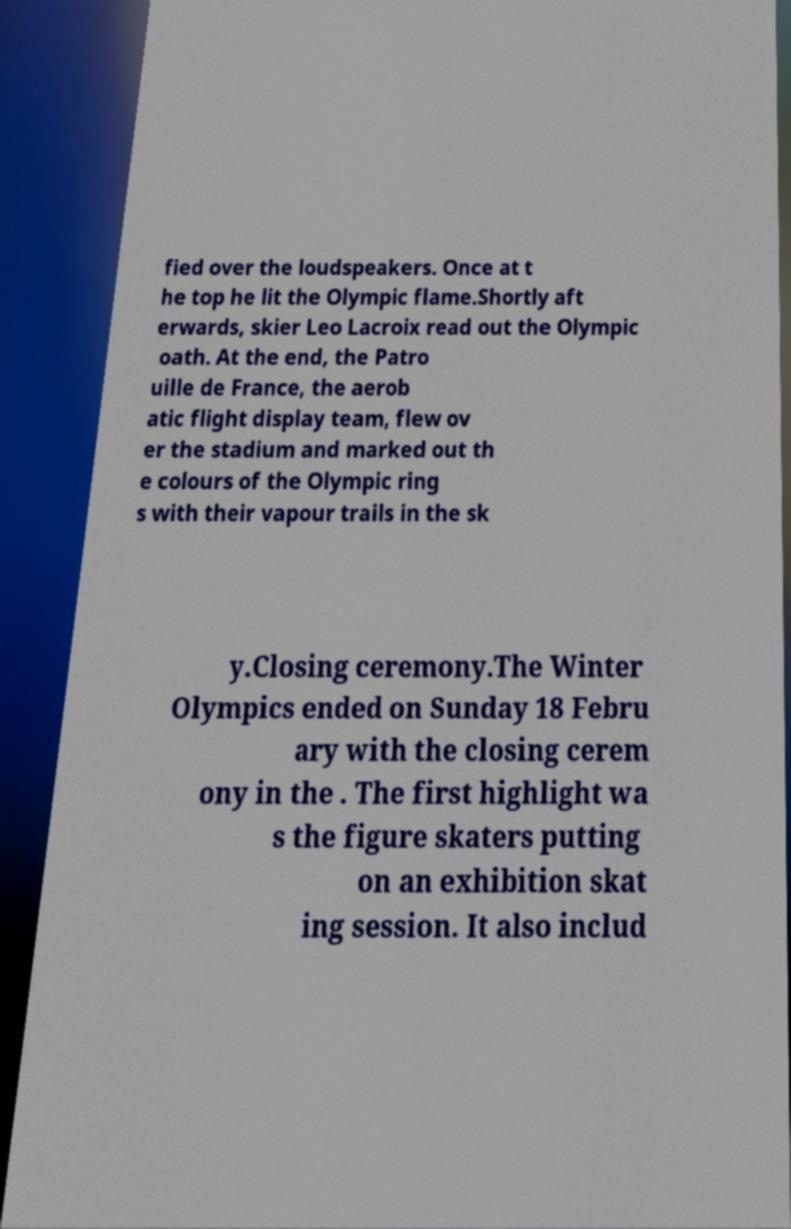Could you assist in decoding the text presented in this image and type it out clearly? fied over the loudspeakers. Once at t he top he lit the Olympic flame.Shortly aft erwards, skier Leo Lacroix read out the Olympic oath. At the end, the Patro uille de France, the aerob atic flight display team, flew ov er the stadium and marked out th e colours of the Olympic ring s with their vapour trails in the sk y.Closing ceremony.The Winter Olympics ended on Sunday 18 Febru ary with the closing cerem ony in the . The first highlight wa s the figure skaters putting on an exhibition skat ing session. It also includ 